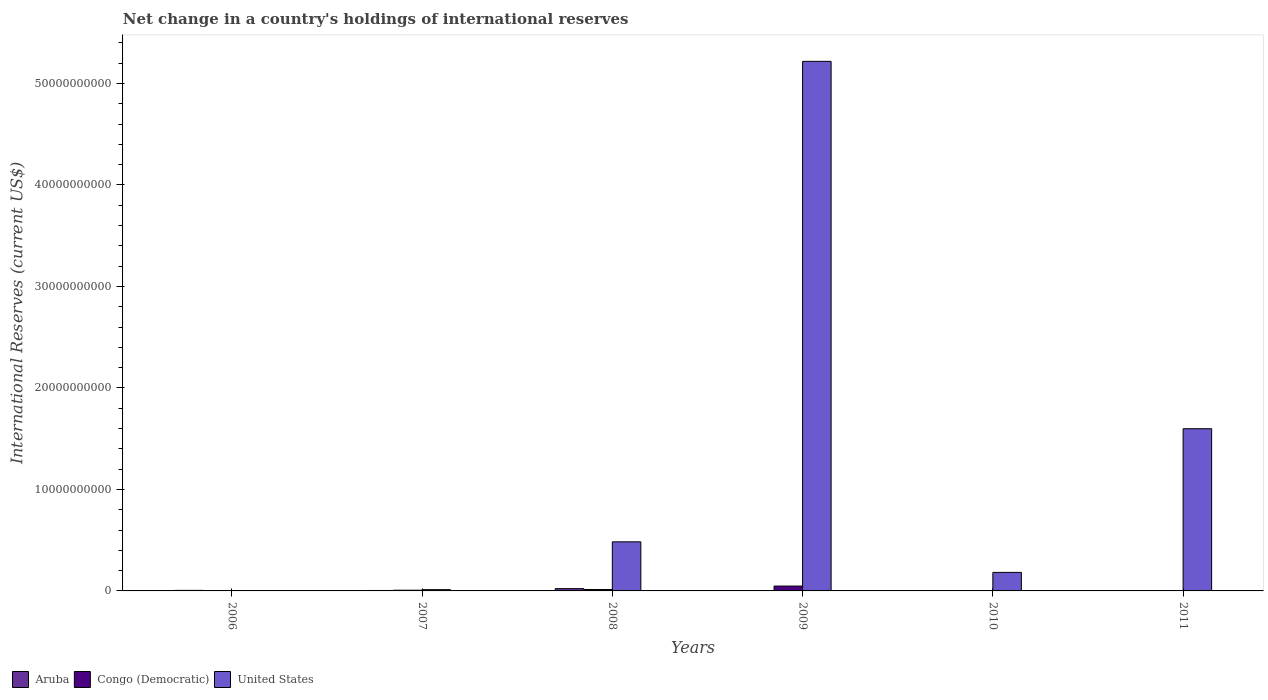How many bars are there on the 1st tick from the left?
Offer a very short reply. 1. What is the label of the 5th group of bars from the left?
Ensure brevity in your answer.  2010. What is the international reserves in United States in 2011?
Offer a very short reply. 1.60e+1. Across all years, what is the maximum international reserves in United States?
Provide a short and direct response. 5.22e+1. Across all years, what is the minimum international reserves in Congo (Democratic)?
Keep it short and to the point. 0. In which year was the international reserves in United States maximum?
Give a very brief answer. 2009. What is the total international reserves in Congo (Democratic) in the graph?
Your response must be concise. 6.88e+08. What is the difference between the international reserves in Aruba in 2006 and that in 2008?
Provide a short and direct response. -1.70e+08. What is the difference between the international reserves in Aruba in 2011 and the international reserves in United States in 2008?
Your answer should be very brief. -4.84e+09. What is the average international reserves in Congo (Democratic) per year?
Your answer should be very brief. 1.15e+08. In the year 2007, what is the difference between the international reserves in United States and international reserves in Congo (Democratic)?
Make the answer very short. 5.44e+07. What is the ratio of the international reserves in Congo (Democratic) in 2007 to that in 2008?
Ensure brevity in your answer.  0.5. Is the difference between the international reserves in United States in 2008 and 2009 greater than the difference between the international reserves in Congo (Democratic) in 2008 and 2009?
Your response must be concise. No. What is the difference between the highest and the second highest international reserves in Congo (Democratic)?
Your response must be concise. 3.41e+08. What is the difference between the highest and the lowest international reserves in Congo (Democratic)?
Provide a short and direct response. 4.80e+08. In how many years, is the international reserves in United States greater than the average international reserves in United States taken over all years?
Give a very brief answer. 2. Is the sum of the international reserves in Congo (Democratic) in 2008 and 2009 greater than the maximum international reserves in United States across all years?
Keep it short and to the point. No. Is it the case that in every year, the sum of the international reserves in Aruba and international reserves in United States is greater than the international reserves in Congo (Democratic)?
Provide a succinct answer. Yes. How many bars are there?
Keep it short and to the point. 12. Are all the bars in the graph horizontal?
Make the answer very short. No. Are the values on the major ticks of Y-axis written in scientific E-notation?
Make the answer very short. No. Where does the legend appear in the graph?
Your response must be concise. Bottom left. How are the legend labels stacked?
Offer a terse response. Horizontal. What is the title of the graph?
Give a very brief answer. Net change in a country's holdings of international reserves. What is the label or title of the Y-axis?
Ensure brevity in your answer.  International Reserves (current US$). What is the International Reserves (current US$) in Aruba in 2006?
Your response must be concise. 5.51e+07. What is the International Reserves (current US$) in Congo (Democratic) in 2006?
Offer a very short reply. 0. What is the International Reserves (current US$) of Aruba in 2007?
Provide a succinct answer. 4.32e+07. What is the International Reserves (current US$) in Congo (Democratic) in 2007?
Your response must be concise. 6.96e+07. What is the International Reserves (current US$) in United States in 2007?
Give a very brief answer. 1.24e+08. What is the International Reserves (current US$) of Aruba in 2008?
Keep it short and to the point. 2.25e+08. What is the International Reserves (current US$) of Congo (Democratic) in 2008?
Your response must be concise. 1.39e+08. What is the International Reserves (current US$) of United States in 2008?
Your answer should be compact. 4.84e+09. What is the International Reserves (current US$) in Aruba in 2009?
Provide a short and direct response. 3.42e+07. What is the International Reserves (current US$) of Congo (Democratic) in 2009?
Your response must be concise. 4.80e+08. What is the International Reserves (current US$) of United States in 2009?
Offer a very short reply. 5.22e+1. What is the International Reserves (current US$) of Aruba in 2010?
Give a very brief answer. 0. What is the International Reserves (current US$) of United States in 2010?
Keep it short and to the point. 1.83e+09. What is the International Reserves (current US$) of Aruba in 2011?
Ensure brevity in your answer.  0. What is the International Reserves (current US$) of Congo (Democratic) in 2011?
Give a very brief answer. 0. What is the International Reserves (current US$) of United States in 2011?
Your response must be concise. 1.60e+1. Across all years, what is the maximum International Reserves (current US$) of Aruba?
Ensure brevity in your answer.  2.25e+08. Across all years, what is the maximum International Reserves (current US$) in Congo (Democratic)?
Provide a succinct answer. 4.80e+08. Across all years, what is the maximum International Reserves (current US$) of United States?
Offer a very short reply. 5.22e+1. Across all years, what is the minimum International Reserves (current US$) in Aruba?
Your answer should be very brief. 0. What is the total International Reserves (current US$) of Aruba in the graph?
Provide a succinct answer. 3.58e+08. What is the total International Reserves (current US$) in Congo (Democratic) in the graph?
Offer a terse response. 6.88e+08. What is the total International Reserves (current US$) of United States in the graph?
Your response must be concise. 7.50e+1. What is the difference between the International Reserves (current US$) in Aruba in 2006 and that in 2007?
Your answer should be very brief. 1.20e+07. What is the difference between the International Reserves (current US$) in Aruba in 2006 and that in 2008?
Your answer should be very brief. -1.70e+08. What is the difference between the International Reserves (current US$) in Aruba in 2006 and that in 2009?
Ensure brevity in your answer.  2.09e+07. What is the difference between the International Reserves (current US$) of Aruba in 2007 and that in 2008?
Your answer should be very brief. -1.82e+08. What is the difference between the International Reserves (current US$) in Congo (Democratic) in 2007 and that in 2008?
Ensure brevity in your answer.  -6.91e+07. What is the difference between the International Reserves (current US$) of United States in 2007 and that in 2008?
Make the answer very short. -4.71e+09. What is the difference between the International Reserves (current US$) of Aruba in 2007 and that in 2009?
Provide a short and direct response. 8.99e+06. What is the difference between the International Reserves (current US$) in Congo (Democratic) in 2007 and that in 2009?
Your response must be concise. -4.10e+08. What is the difference between the International Reserves (current US$) in United States in 2007 and that in 2009?
Offer a very short reply. -5.21e+1. What is the difference between the International Reserves (current US$) of United States in 2007 and that in 2010?
Your answer should be very brief. -1.70e+09. What is the difference between the International Reserves (current US$) in United States in 2007 and that in 2011?
Provide a succinct answer. -1.59e+1. What is the difference between the International Reserves (current US$) in Aruba in 2008 and that in 2009?
Ensure brevity in your answer.  1.91e+08. What is the difference between the International Reserves (current US$) of Congo (Democratic) in 2008 and that in 2009?
Ensure brevity in your answer.  -3.41e+08. What is the difference between the International Reserves (current US$) in United States in 2008 and that in 2009?
Ensure brevity in your answer.  -4.73e+1. What is the difference between the International Reserves (current US$) of United States in 2008 and that in 2010?
Offer a terse response. 3.01e+09. What is the difference between the International Reserves (current US$) in United States in 2008 and that in 2011?
Provide a short and direct response. -1.11e+1. What is the difference between the International Reserves (current US$) in United States in 2009 and that in 2010?
Keep it short and to the point. 5.04e+1. What is the difference between the International Reserves (current US$) in United States in 2009 and that in 2011?
Your answer should be compact. 3.62e+1. What is the difference between the International Reserves (current US$) in United States in 2010 and that in 2011?
Make the answer very short. -1.42e+1. What is the difference between the International Reserves (current US$) of Aruba in 2006 and the International Reserves (current US$) of Congo (Democratic) in 2007?
Ensure brevity in your answer.  -1.45e+07. What is the difference between the International Reserves (current US$) in Aruba in 2006 and the International Reserves (current US$) in United States in 2007?
Give a very brief answer. -6.89e+07. What is the difference between the International Reserves (current US$) of Aruba in 2006 and the International Reserves (current US$) of Congo (Democratic) in 2008?
Give a very brief answer. -8.36e+07. What is the difference between the International Reserves (current US$) in Aruba in 2006 and the International Reserves (current US$) in United States in 2008?
Offer a terse response. -4.78e+09. What is the difference between the International Reserves (current US$) of Aruba in 2006 and the International Reserves (current US$) of Congo (Democratic) in 2009?
Ensure brevity in your answer.  -4.24e+08. What is the difference between the International Reserves (current US$) in Aruba in 2006 and the International Reserves (current US$) in United States in 2009?
Make the answer very short. -5.21e+1. What is the difference between the International Reserves (current US$) of Aruba in 2006 and the International Reserves (current US$) of United States in 2010?
Ensure brevity in your answer.  -1.77e+09. What is the difference between the International Reserves (current US$) of Aruba in 2006 and the International Reserves (current US$) of United States in 2011?
Give a very brief answer. -1.59e+1. What is the difference between the International Reserves (current US$) of Aruba in 2007 and the International Reserves (current US$) of Congo (Democratic) in 2008?
Your response must be concise. -9.56e+07. What is the difference between the International Reserves (current US$) of Aruba in 2007 and the International Reserves (current US$) of United States in 2008?
Make the answer very short. -4.79e+09. What is the difference between the International Reserves (current US$) of Congo (Democratic) in 2007 and the International Reserves (current US$) of United States in 2008?
Your answer should be very brief. -4.77e+09. What is the difference between the International Reserves (current US$) in Aruba in 2007 and the International Reserves (current US$) in Congo (Democratic) in 2009?
Your answer should be very brief. -4.36e+08. What is the difference between the International Reserves (current US$) of Aruba in 2007 and the International Reserves (current US$) of United States in 2009?
Give a very brief answer. -5.21e+1. What is the difference between the International Reserves (current US$) of Congo (Democratic) in 2007 and the International Reserves (current US$) of United States in 2009?
Provide a succinct answer. -5.21e+1. What is the difference between the International Reserves (current US$) of Aruba in 2007 and the International Reserves (current US$) of United States in 2010?
Your answer should be very brief. -1.78e+09. What is the difference between the International Reserves (current US$) of Congo (Democratic) in 2007 and the International Reserves (current US$) of United States in 2010?
Ensure brevity in your answer.  -1.76e+09. What is the difference between the International Reserves (current US$) in Aruba in 2007 and the International Reserves (current US$) in United States in 2011?
Provide a succinct answer. -1.59e+1. What is the difference between the International Reserves (current US$) in Congo (Democratic) in 2007 and the International Reserves (current US$) in United States in 2011?
Keep it short and to the point. -1.59e+1. What is the difference between the International Reserves (current US$) in Aruba in 2008 and the International Reserves (current US$) in Congo (Democratic) in 2009?
Your answer should be compact. -2.54e+08. What is the difference between the International Reserves (current US$) in Aruba in 2008 and the International Reserves (current US$) in United States in 2009?
Give a very brief answer. -5.20e+1. What is the difference between the International Reserves (current US$) of Congo (Democratic) in 2008 and the International Reserves (current US$) of United States in 2009?
Provide a short and direct response. -5.20e+1. What is the difference between the International Reserves (current US$) of Aruba in 2008 and the International Reserves (current US$) of United States in 2010?
Give a very brief answer. -1.60e+09. What is the difference between the International Reserves (current US$) of Congo (Democratic) in 2008 and the International Reserves (current US$) of United States in 2010?
Offer a terse response. -1.69e+09. What is the difference between the International Reserves (current US$) of Aruba in 2008 and the International Reserves (current US$) of United States in 2011?
Your answer should be compact. -1.58e+1. What is the difference between the International Reserves (current US$) of Congo (Democratic) in 2008 and the International Reserves (current US$) of United States in 2011?
Give a very brief answer. -1.58e+1. What is the difference between the International Reserves (current US$) of Aruba in 2009 and the International Reserves (current US$) of United States in 2010?
Your answer should be very brief. -1.79e+09. What is the difference between the International Reserves (current US$) of Congo (Democratic) in 2009 and the International Reserves (current US$) of United States in 2010?
Your answer should be very brief. -1.35e+09. What is the difference between the International Reserves (current US$) of Aruba in 2009 and the International Reserves (current US$) of United States in 2011?
Provide a short and direct response. -1.59e+1. What is the difference between the International Reserves (current US$) of Congo (Democratic) in 2009 and the International Reserves (current US$) of United States in 2011?
Provide a short and direct response. -1.55e+1. What is the average International Reserves (current US$) of Aruba per year?
Offer a very short reply. 5.96e+07. What is the average International Reserves (current US$) of Congo (Democratic) per year?
Your answer should be very brief. 1.15e+08. What is the average International Reserves (current US$) of United States per year?
Make the answer very short. 1.25e+1. In the year 2007, what is the difference between the International Reserves (current US$) of Aruba and International Reserves (current US$) of Congo (Democratic)?
Provide a succinct answer. -2.64e+07. In the year 2007, what is the difference between the International Reserves (current US$) of Aruba and International Reserves (current US$) of United States?
Ensure brevity in your answer.  -8.08e+07. In the year 2007, what is the difference between the International Reserves (current US$) in Congo (Democratic) and International Reserves (current US$) in United States?
Ensure brevity in your answer.  -5.44e+07. In the year 2008, what is the difference between the International Reserves (current US$) of Aruba and International Reserves (current US$) of Congo (Democratic)?
Provide a succinct answer. 8.66e+07. In the year 2008, what is the difference between the International Reserves (current US$) of Aruba and International Reserves (current US$) of United States?
Provide a succinct answer. -4.61e+09. In the year 2008, what is the difference between the International Reserves (current US$) of Congo (Democratic) and International Reserves (current US$) of United States?
Your response must be concise. -4.70e+09. In the year 2009, what is the difference between the International Reserves (current US$) of Aruba and International Reserves (current US$) of Congo (Democratic)?
Your response must be concise. -4.45e+08. In the year 2009, what is the difference between the International Reserves (current US$) of Aruba and International Reserves (current US$) of United States?
Provide a short and direct response. -5.21e+1. In the year 2009, what is the difference between the International Reserves (current US$) in Congo (Democratic) and International Reserves (current US$) in United States?
Your answer should be compact. -5.17e+1. What is the ratio of the International Reserves (current US$) of Aruba in 2006 to that in 2007?
Your answer should be very brief. 1.28. What is the ratio of the International Reserves (current US$) of Aruba in 2006 to that in 2008?
Your response must be concise. 0.24. What is the ratio of the International Reserves (current US$) of Aruba in 2006 to that in 2009?
Provide a short and direct response. 1.61. What is the ratio of the International Reserves (current US$) in Aruba in 2007 to that in 2008?
Provide a short and direct response. 0.19. What is the ratio of the International Reserves (current US$) of Congo (Democratic) in 2007 to that in 2008?
Your answer should be compact. 0.5. What is the ratio of the International Reserves (current US$) in United States in 2007 to that in 2008?
Offer a very short reply. 0.03. What is the ratio of the International Reserves (current US$) in Aruba in 2007 to that in 2009?
Offer a terse response. 1.26. What is the ratio of the International Reserves (current US$) in Congo (Democratic) in 2007 to that in 2009?
Offer a very short reply. 0.15. What is the ratio of the International Reserves (current US$) of United States in 2007 to that in 2009?
Your response must be concise. 0. What is the ratio of the International Reserves (current US$) of United States in 2007 to that in 2010?
Keep it short and to the point. 0.07. What is the ratio of the International Reserves (current US$) in United States in 2007 to that in 2011?
Keep it short and to the point. 0.01. What is the ratio of the International Reserves (current US$) in Aruba in 2008 to that in 2009?
Your answer should be very brief. 6.59. What is the ratio of the International Reserves (current US$) in Congo (Democratic) in 2008 to that in 2009?
Keep it short and to the point. 0.29. What is the ratio of the International Reserves (current US$) of United States in 2008 to that in 2009?
Provide a short and direct response. 0.09. What is the ratio of the International Reserves (current US$) in United States in 2008 to that in 2010?
Your response must be concise. 2.65. What is the ratio of the International Reserves (current US$) in United States in 2008 to that in 2011?
Ensure brevity in your answer.  0.3. What is the ratio of the International Reserves (current US$) in United States in 2009 to that in 2010?
Your answer should be very brief. 28.59. What is the ratio of the International Reserves (current US$) in United States in 2009 to that in 2011?
Give a very brief answer. 3.26. What is the ratio of the International Reserves (current US$) of United States in 2010 to that in 2011?
Give a very brief answer. 0.11. What is the difference between the highest and the second highest International Reserves (current US$) in Aruba?
Provide a succinct answer. 1.70e+08. What is the difference between the highest and the second highest International Reserves (current US$) of Congo (Democratic)?
Give a very brief answer. 3.41e+08. What is the difference between the highest and the second highest International Reserves (current US$) in United States?
Provide a succinct answer. 3.62e+1. What is the difference between the highest and the lowest International Reserves (current US$) in Aruba?
Your response must be concise. 2.25e+08. What is the difference between the highest and the lowest International Reserves (current US$) of Congo (Democratic)?
Give a very brief answer. 4.80e+08. What is the difference between the highest and the lowest International Reserves (current US$) in United States?
Keep it short and to the point. 5.22e+1. 